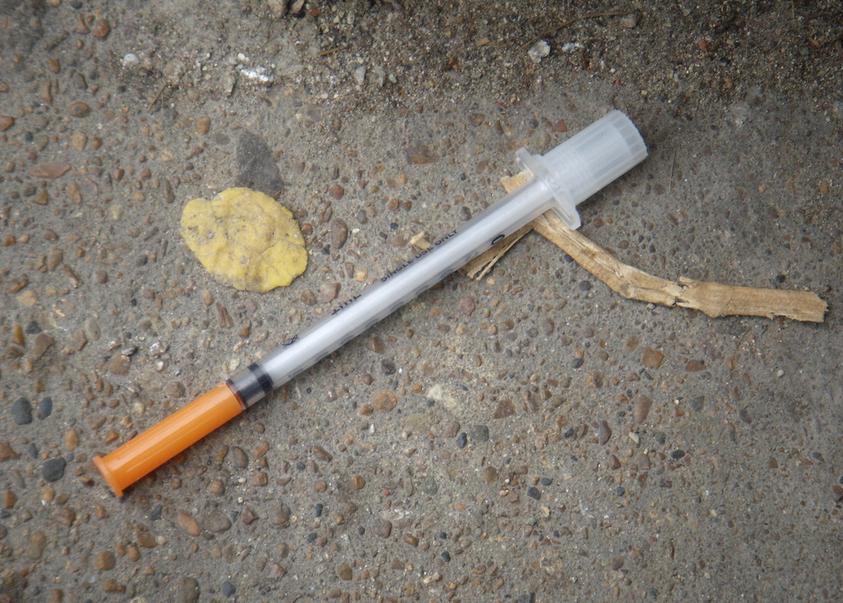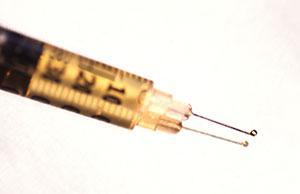The first image is the image on the left, the second image is the image on the right. Analyze the images presented: Is the assertion "The image on the left contains exactly one syringe with an orange cap." valid? Answer yes or no. Yes. 